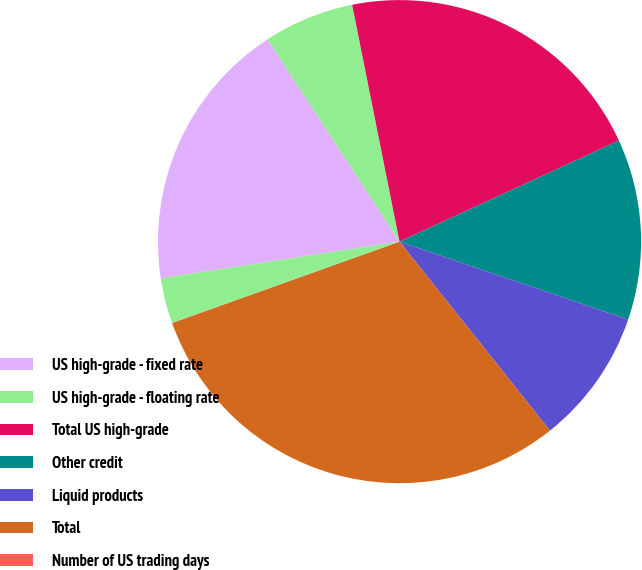Convert chart to OTSL. <chart><loc_0><loc_0><loc_500><loc_500><pie_chart><fcel>US high-grade - fixed rate<fcel>US high-grade - floating rate<fcel>Total US high-grade<fcel>Other credit<fcel>Liquid products<fcel>Total<fcel>Number of US trading days<fcel>Number of UK trading days<nl><fcel>18.24%<fcel>6.05%<fcel>21.27%<fcel>12.1%<fcel>9.07%<fcel>30.23%<fcel>0.01%<fcel>3.03%<nl></chart> 